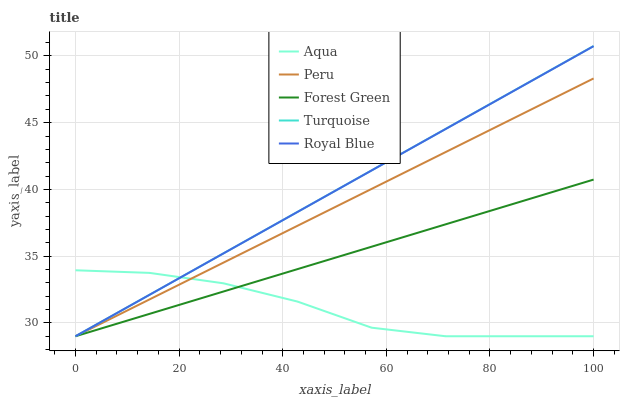Does Aqua have the minimum area under the curve?
Answer yes or no. Yes. Does Turquoise have the maximum area under the curve?
Answer yes or no. Yes. Does Forest Green have the minimum area under the curve?
Answer yes or no. No. Does Forest Green have the maximum area under the curve?
Answer yes or no. No. Is Peru the smoothest?
Answer yes or no. Yes. Is Aqua the roughest?
Answer yes or no. Yes. Is Forest Green the smoothest?
Answer yes or no. No. Is Forest Green the roughest?
Answer yes or no. No. Does Royal Blue have the lowest value?
Answer yes or no. Yes. Does Turquoise have the highest value?
Answer yes or no. Yes. Does Forest Green have the highest value?
Answer yes or no. No. Does Turquoise intersect Forest Green?
Answer yes or no. Yes. Is Turquoise less than Forest Green?
Answer yes or no. No. Is Turquoise greater than Forest Green?
Answer yes or no. No. 